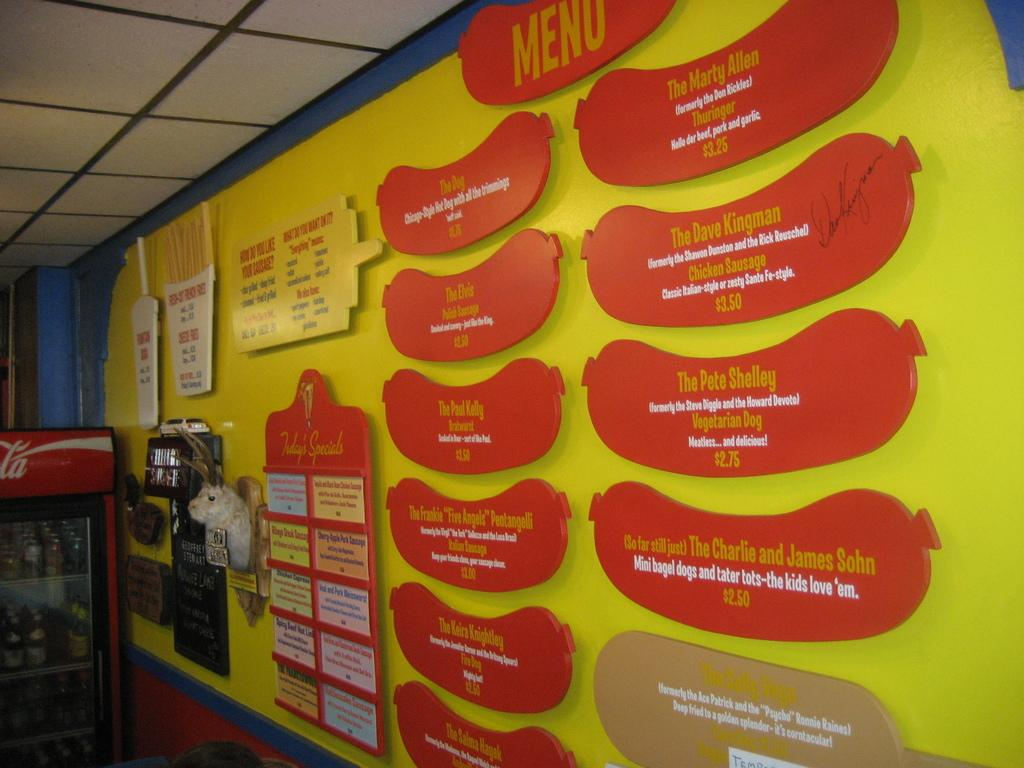<image>
Relay a brief, clear account of the picture shown. a yellow wall in a room with a sign on it that says 'menu' 